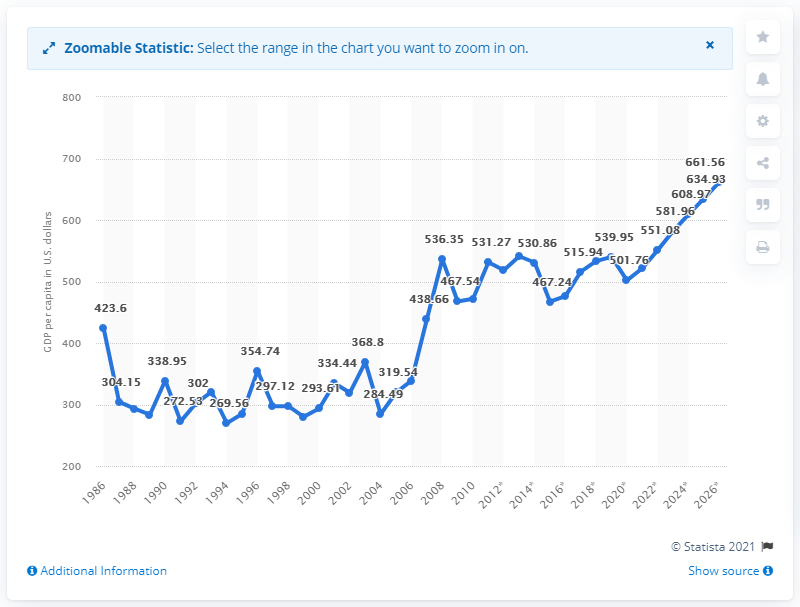Identify some key points in this picture. According to data from 2020, the Gross Domestic Product (GDP) per capita in Madagascar was 501.76. 